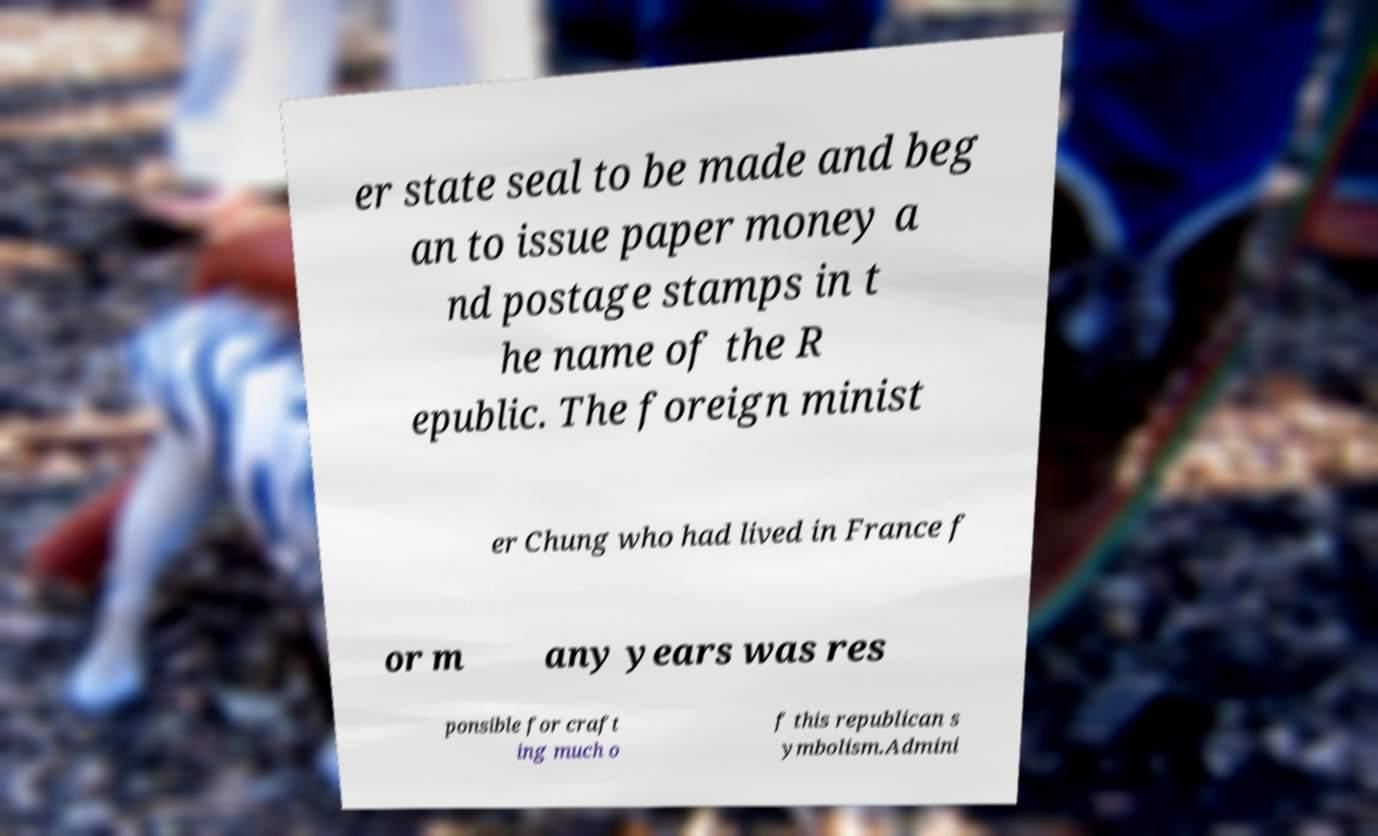Please read and relay the text visible in this image. What does it say? er state seal to be made and beg an to issue paper money a nd postage stamps in t he name of the R epublic. The foreign minist er Chung who had lived in France f or m any years was res ponsible for craft ing much o f this republican s ymbolism.Admini 